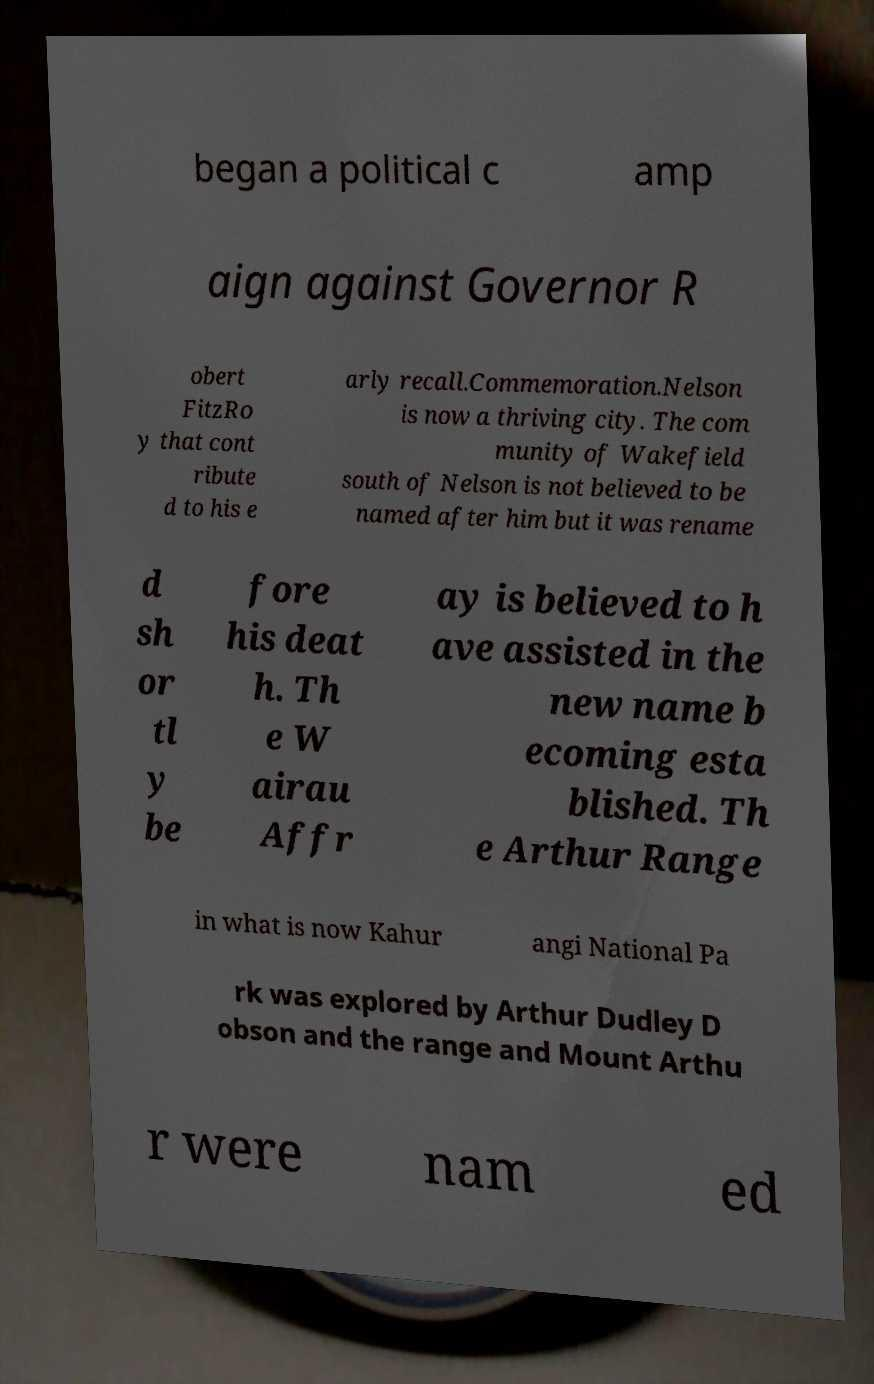Could you assist in decoding the text presented in this image and type it out clearly? began a political c amp aign against Governor R obert FitzRo y that cont ribute d to his e arly recall.Commemoration.Nelson is now a thriving city. The com munity of Wakefield south of Nelson is not believed to be named after him but it was rename d sh or tl y be fore his deat h. Th e W airau Affr ay is believed to h ave assisted in the new name b ecoming esta blished. Th e Arthur Range in what is now Kahur angi National Pa rk was explored by Arthur Dudley D obson and the range and Mount Arthu r were nam ed 